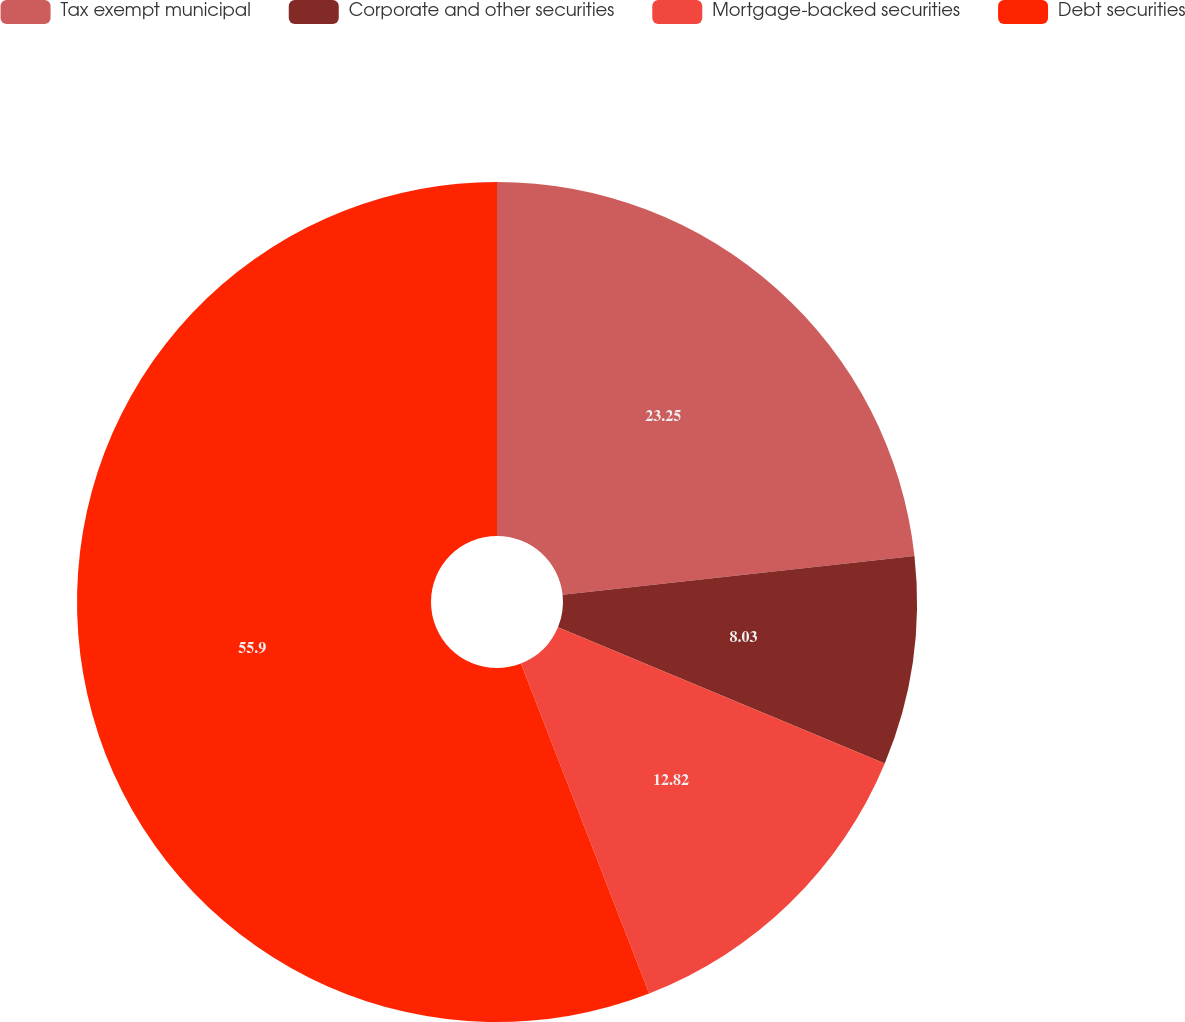<chart> <loc_0><loc_0><loc_500><loc_500><pie_chart><fcel>Tax exempt municipal<fcel>Corporate and other securities<fcel>Mortgage-backed securities<fcel>Debt securities<nl><fcel>23.25%<fcel>8.03%<fcel>12.82%<fcel>55.9%<nl></chart> 